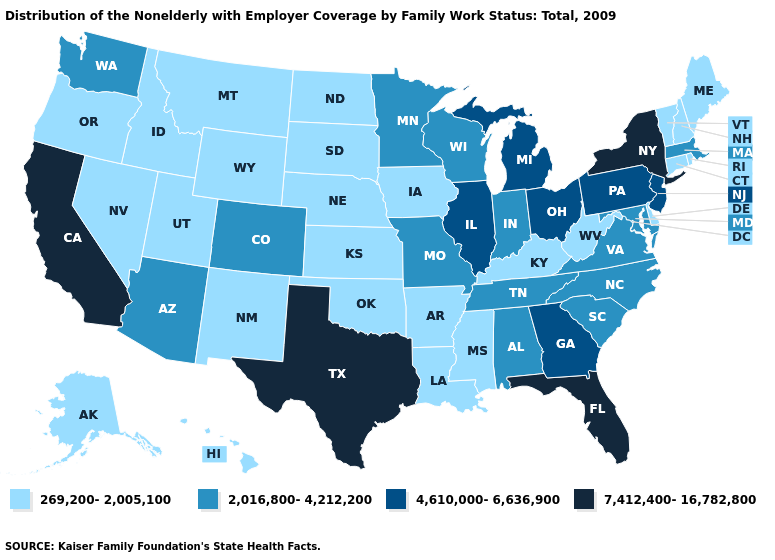Which states have the highest value in the USA?
Quick response, please. California, Florida, New York, Texas. What is the value of Maine?
Keep it brief. 269,200-2,005,100. Name the states that have a value in the range 4,610,000-6,636,900?
Quick response, please. Georgia, Illinois, Michigan, New Jersey, Ohio, Pennsylvania. What is the lowest value in states that border Delaware?
Keep it brief. 2,016,800-4,212,200. Does Alabama have the lowest value in the South?
Keep it brief. No. Which states have the lowest value in the West?
Write a very short answer. Alaska, Hawaii, Idaho, Montana, Nevada, New Mexico, Oregon, Utah, Wyoming. Which states hav the highest value in the MidWest?
Concise answer only. Illinois, Michigan, Ohio. Name the states that have a value in the range 7,412,400-16,782,800?
Keep it brief. California, Florida, New York, Texas. Does New York have the same value as Texas?
Quick response, please. Yes. Which states have the highest value in the USA?
Short answer required. California, Florida, New York, Texas. Does Ohio have the highest value in the USA?
Answer briefly. No. Does Mississippi have the highest value in the South?
Answer briefly. No. What is the highest value in the USA?
Concise answer only. 7,412,400-16,782,800. What is the value of North Carolina?
Concise answer only. 2,016,800-4,212,200. Name the states that have a value in the range 4,610,000-6,636,900?
Concise answer only. Georgia, Illinois, Michigan, New Jersey, Ohio, Pennsylvania. 